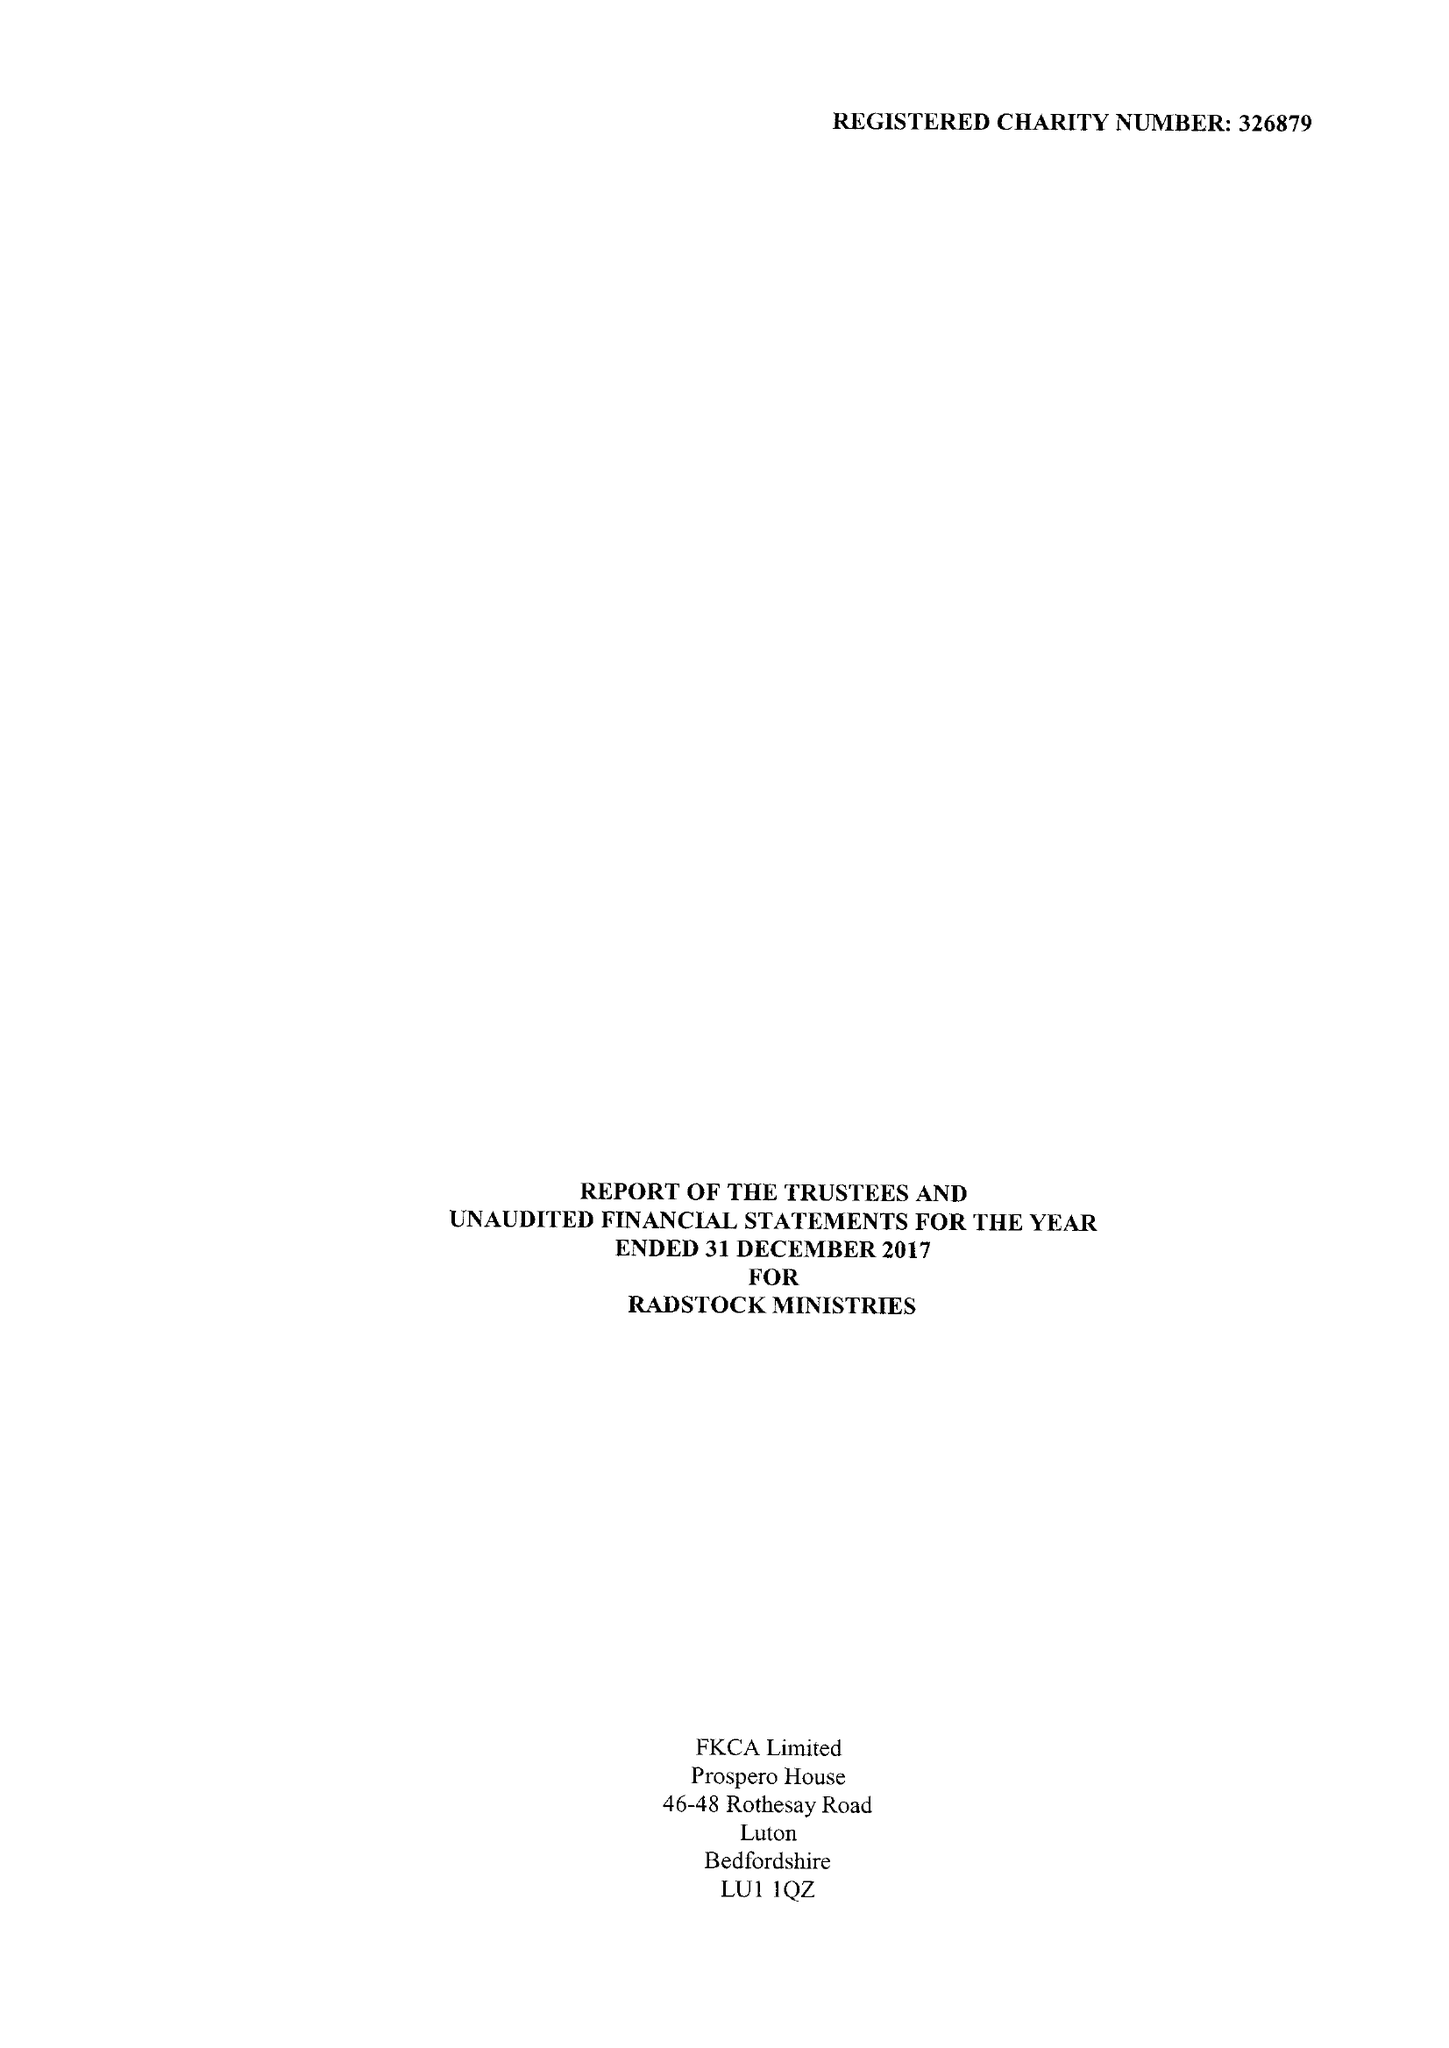What is the value for the address__street_line?
Answer the question using a single word or phrase. ST THOMAS'S ROAD 